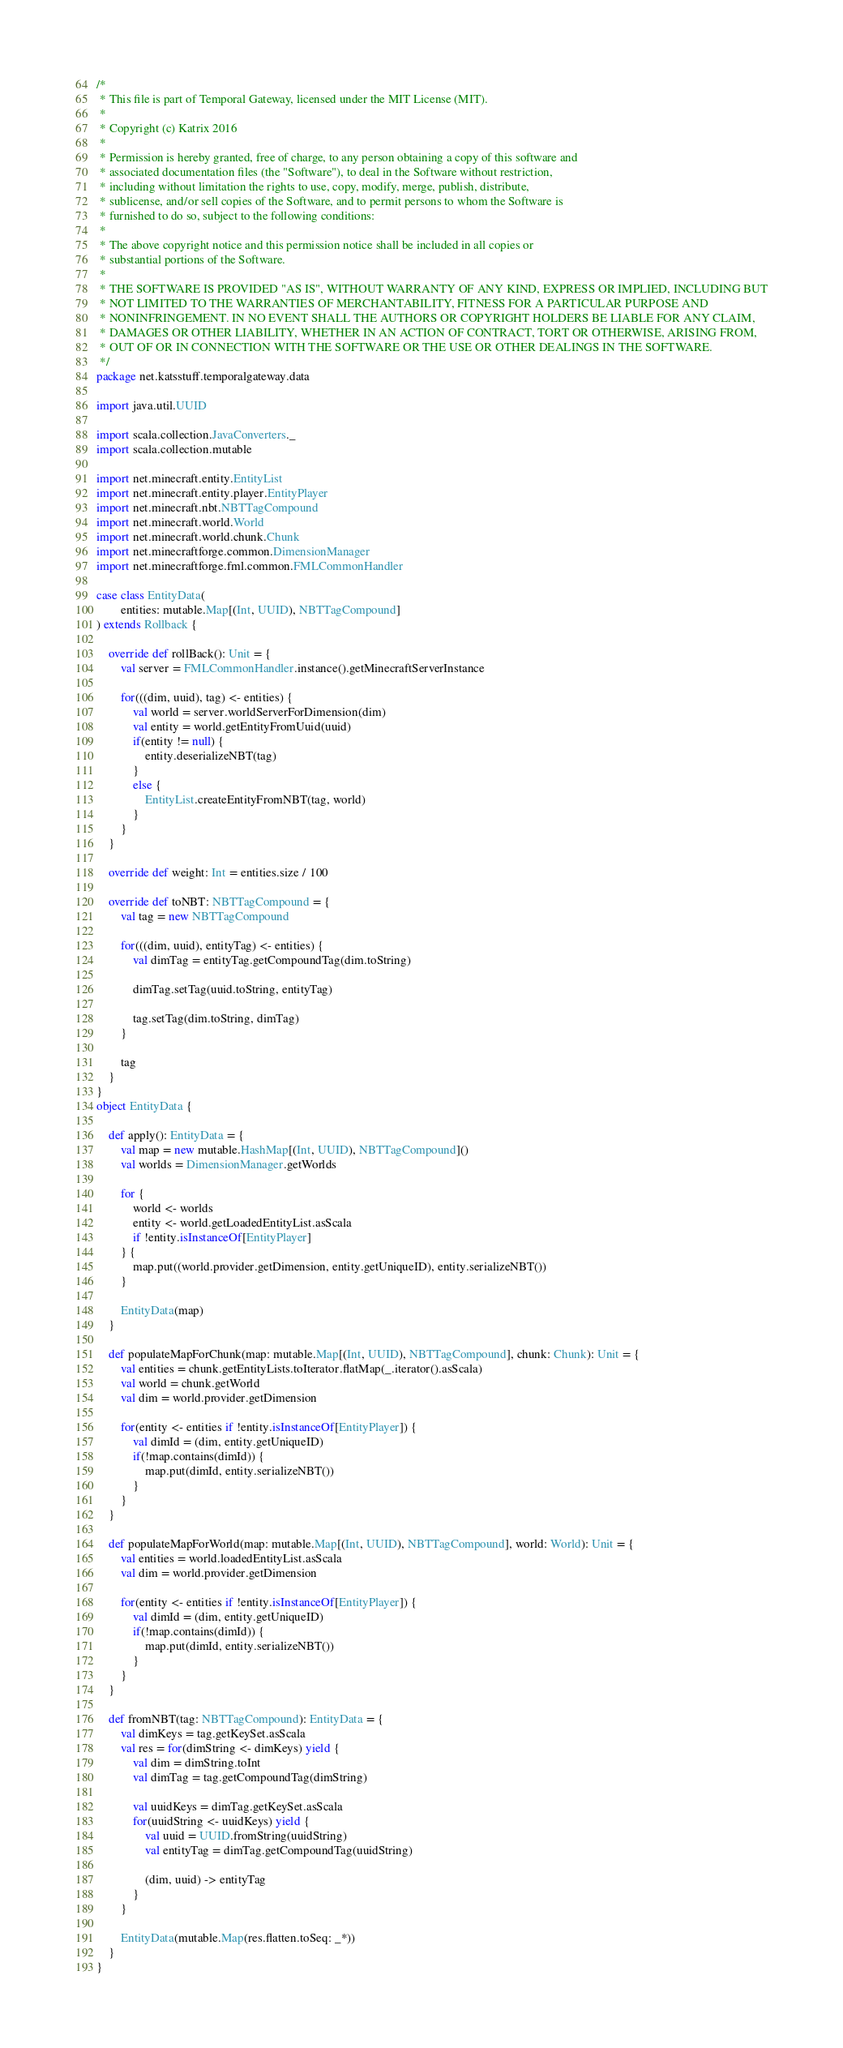Convert code to text. <code><loc_0><loc_0><loc_500><loc_500><_Scala_>/*
 * This file is part of Temporal Gateway, licensed under the MIT License (MIT).
 *
 * Copyright (c) Katrix 2016
 *
 * Permission is hereby granted, free of charge, to any person obtaining a copy of this software and
 * associated documentation files (the "Software"), to deal in the Software without restriction,
 * including without limitation the rights to use, copy, modify, merge, publish, distribute,
 * sublicense, and/or sell copies of the Software, and to permit persons to whom the Software is
 * furnished to do so, subject to the following conditions:
 *
 * The above copyright notice and this permission notice shall be included in all copies or
 * substantial portions of the Software.
 *
 * THE SOFTWARE IS PROVIDED "AS IS", WITHOUT WARRANTY OF ANY KIND, EXPRESS OR IMPLIED, INCLUDING BUT
 * NOT LIMITED TO THE WARRANTIES OF MERCHANTABILITY, FITNESS FOR A PARTICULAR PURPOSE AND
 * NONINFRINGEMENT. IN NO EVENT SHALL THE AUTHORS OR COPYRIGHT HOLDERS BE LIABLE FOR ANY CLAIM,
 * DAMAGES OR OTHER LIABILITY, WHETHER IN AN ACTION OF CONTRACT, TORT OR OTHERWISE, ARISING FROM,
 * OUT OF OR IN CONNECTION WITH THE SOFTWARE OR THE USE OR OTHER DEALINGS IN THE SOFTWARE.
 */
package net.katsstuff.temporalgateway.data

import java.util.UUID

import scala.collection.JavaConverters._
import scala.collection.mutable

import net.minecraft.entity.EntityList
import net.minecraft.entity.player.EntityPlayer
import net.minecraft.nbt.NBTTagCompound
import net.minecraft.world.World
import net.minecraft.world.chunk.Chunk
import net.minecraftforge.common.DimensionManager
import net.minecraftforge.fml.common.FMLCommonHandler

case class EntityData(
		entities: mutable.Map[(Int, UUID), NBTTagCompound]
) extends Rollback {

	override def rollBack(): Unit = {
		val server = FMLCommonHandler.instance().getMinecraftServerInstance

		for(((dim, uuid), tag) <- entities) {
			val world = server.worldServerForDimension(dim)
			val entity = world.getEntityFromUuid(uuid)
			if(entity != null) {
				entity.deserializeNBT(tag)
			}
			else {
				EntityList.createEntityFromNBT(tag, world)
			}
		}
	}

	override def weight: Int = entities.size / 100

	override def toNBT: NBTTagCompound = {
		val tag = new NBTTagCompound

		for(((dim, uuid), entityTag) <- entities) {
			val dimTag = entityTag.getCompoundTag(dim.toString)

			dimTag.setTag(uuid.toString, entityTag)

			tag.setTag(dim.toString, dimTag)
		}

		tag
	}
}
object EntityData {

	def apply(): EntityData = {
		val map = new mutable.HashMap[(Int, UUID), NBTTagCompound]()
		val worlds = DimensionManager.getWorlds

		for {
			world <- worlds
			entity <- world.getLoadedEntityList.asScala
			if !entity.isInstanceOf[EntityPlayer]
		} {
			map.put((world.provider.getDimension, entity.getUniqueID), entity.serializeNBT())
		}

		EntityData(map)
	}

	def populateMapForChunk(map: mutable.Map[(Int, UUID), NBTTagCompound], chunk: Chunk): Unit = {
		val entities = chunk.getEntityLists.toIterator.flatMap(_.iterator().asScala)
		val world = chunk.getWorld
		val dim = world.provider.getDimension

		for(entity <- entities if !entity.isInstanceOf[EntityPlayer]) {
			val dimId = (dim, entity.getUniqueID)
			if(!map.contains(dimId)) {
				map.put(dimId, entity.serializeNBT())
			}
		}
	}

	def populateMapForWorld(map: mutable.Map[(Int, UUID), NBTTagCompound], world: World): Unit = {
		val entities = world.loadedEntityList.asScala
		val dim = world.provider.getDimension

		for(entity <- entities if !entity.isInstanceOf[EntityPlayer]) {
			val dimId = (dim, entity.getUniqueID)
			if(!map.contains(dimId)) {
				map.put(dimId, entity.serializeNBT())
			}
		}
	}

	def fromNBT(tag: NBTTagCompound): EntityData = {
		val dimKeys = tag.getKeySet.asScala
		val res = for(dimString <- dimKeys) yield {
			val dim = dimString.toInt
			val dimTag = tag.getCompoundTag(dimString)

			val uuidKeys = dimTag.getKeySet.asScala
			for(uuidString <- uuidKeys) yield {
				val uuid = UUID.fromString(uuidString)
				val entityTag = dimTag.getCompoundTag(uuidString)

				(dim, uuid) -> entityTag
			}
		}

		EntityData(mutable.Map(res.flatten.toSeq: _*))
	}
}</code> 